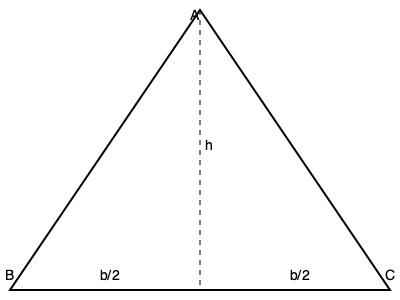In the cross-sectional diagram of an ancient Egyptian pyramid shown above, the height is represented by $h$ and the base width by $b$. If the volume of the pyramid is given by the formula $V = \frac{1}{3}b^2h$, and the ratio of the height to half the base width is 4:3, express the volume in terms of $h$ only. To solve this problem, let's follow these steps:

1. We know that the ratio of height to half the base width is 4:3. This can be expressed as:
   $\frac{h}{\frac{b}{2}} = \frac{4}{3}$

2. Rearrange this equation to express $b$ in terms of $h$:
   $b = \frac{3h}{2}$

3. Now, let's substitute this expression for $b$ into the volume formula:
   $V = \frac{1}{3}b^2h$
   $V = \frac{1}{3}(\frac{3h}{2})^2h$

4. Simplify the expression:
   $V = \frac{1}{3}(\frac{9h^2}{4})h$
   $V = \frac{1}{3} \cdot \frac{9h^3}{4}$
   $V = \frac{3h^3}{4}$

5. Therefore, the volume of the pyramid expressed only in terms of $h$ is:
   $V = \frac{3h^3}{4}$
Answer: $V = \frac{3h^3}{4}$ 